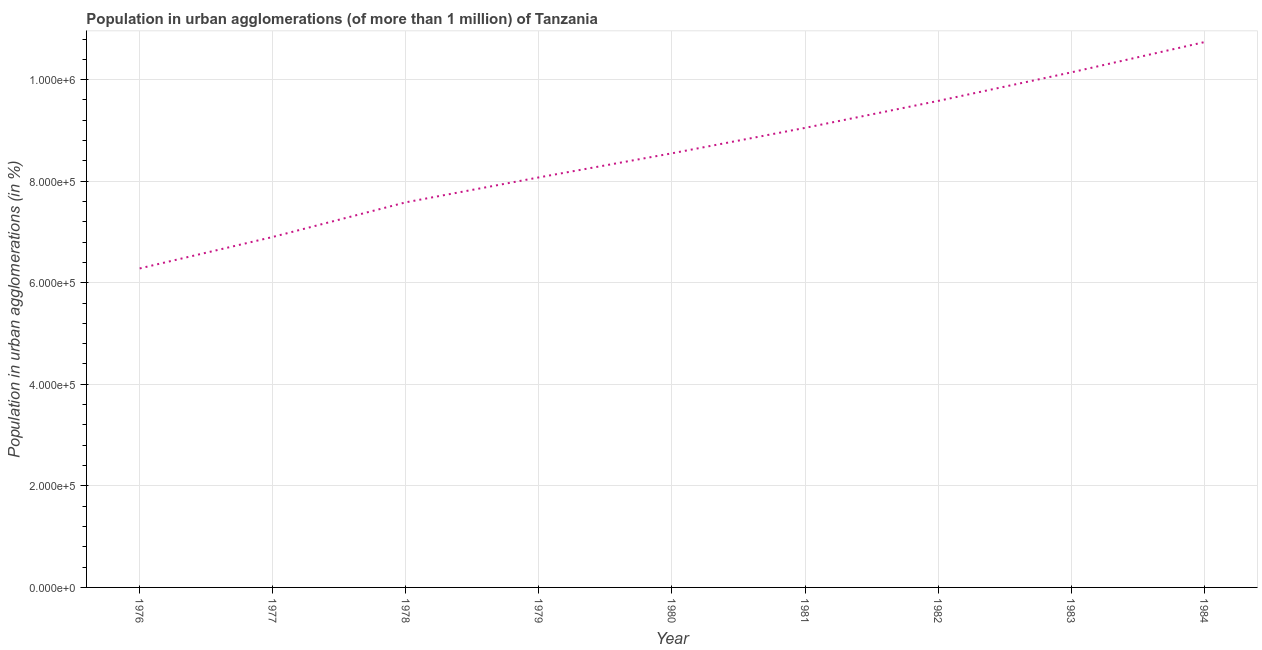What is the population in urban agglomerations in 1981?
Provide a short and direct response. 9.05e+05. Across all years, what is the maximum population in urban agglomerations?
Offer a terse response. 1.07e+06. Across all years, what is the minimum population in urban agglomerations?
Offer a very short reply. 6.28e+05. In which year was the population in urban agglomerations maximum?
Make the answer very short. 1984. In which year was the population in urban agglomerations minimum?
Provide a succinct answer. 1976. What is the sum of the population in urban agglomerations?
Your answer should be compact. 7.69e+06. What is the difference between the population in urban agglomerations in 1977 and 1978?
Your answer should be compact. -6.82e+04. What is the average population in urban agglomerations per year?
Give a very brief answer. 8.54e+05. What is the median population in urban agglomerations?
Give a very brief answer. 8.55e+05. What is the ratio of the population in urban agglomerations in 1977 to that in 1984?
Offer a terse response. 0.64. Is the difference between the population in urban agglomerations in 1976 and 1978 greater than the difference between any two years?
Offer a very short reply. No. What is the difference between the highest and the second highest population in urban agglomerations?
Your response must be concise. 5.96e+04. What is the difference between the highest and the lowest population in urban agglomerations?
Give a very brief answer. 4.46e+05. In how many years, is the population in urban agglomerations greater than the average population in urban agglomerations taken over all years?
Offer a terse response. 5. Does the population in urban agglomerations monotonically increase over the years?
Give a very brief answer. Yes. How many lines are there?
Provide a succinct answer. 1. How many years are there in the graph?
Your answer should be compact. 9. Does the graph contain any zero values?
Make the answer very short. No. What is the title of the graph?
Make the answer very short. Population in urban agglomerations (of more than 1 million) of Tanzania. What is the label or title of the X-axis?
Keep it short and to the point. Year. What is the label or title of the Y-axis?
Ensure brevity in your answer.  Population in urban agglomerations (in %). What is the Population in urban agglomerations (in %) in 1976?
Offer a very short reply. 6.28e+05. What is the Population in urban agglomerations (in %) of 1977?
Offer a very short reply. 6.90e+05. What is the Population in urban agglomerations (in %) of 1978?
Provide a short and direct response. 7.58e+05. What is the Population in urban agglomerations (in %) in 1979?
Offer a very short reply. 8.07e+05. What is the Population in urban agglomerations (in %) in 1980?
Provide a succinct answer. 8.55e+05. What is the Population in urban agglomerations (in %) of 1981?
Your answer should be compact. 9.05e+05. What is the Population in urban agglomerations (in %) in 1982?
Keep it short and to the point. 9.58e+05. What is the Population in urban agglomerations (in %) of 1983?
Provide a succinct answer. 1.01e+06. What is the Population in urban agglomerations (in %) in 1984?
Offer a very short reply. 1.07e+06. What is the difference between the Population in urban agglomerations (in %) in 1976 and 1977?
Give a very brief answer. -6.20e+04. What is the difference between the Population in urban agglomerations (in %) in 1976 and 1978?
Offer a terse response. -1.30e+05. What is the difference between the Population in urban agglomerations (in %) in 1976 and 1979?
Offer a terse response. -1.79e+05. What is the difference between the Population in urban agglomerations (in %) in 1976 and 1980?
Ensure brevity in your answer.  -2.27e+05. What is the difference between the Population in urban agglomerations (in %) in 1976 and 1981?
Your response must be concise. -2.77e+05. What is the difference between the Population in urban agglomerations (in %) in 1976 and 1982?
Make the answer very short. -3.30e+05. What is the difference between the Population in urban agglomerations (in %) in 1976 and 1983?
Offer a very short reply. -3.86e+05. What is the difference between the Population in urban agglomerations (in %) in 1976 and 1984?
Offer a very short reply. -4.46e+05. What is the difference between the Population in urban agglomerations (in %) in 1977 and 1978?
Offer a terse response. -6.82e+04. What is the difference between the Population in urban agglomerations (in %) in 1977 and 1979?
Keep it short and to the point. -1.17e+05. What is the difference between the Population in urban agglomerations (in %) in 1977 and 1980?
Keep it short and to the point. -1.65e+05. What is the difference between the Population in urban agglomerations (in %) in 1977 and 1981?
Make the answer very short. -2.15e+05. What is the difference between the Population in urban agglomerations (in %) in 1977 and 1982?
Offer a terse response. -2.68e+05. What is the difference between the Population in urban agglomerations (in %) in 1977 and 1983?
Give a very brief answer. -3.24e+05. What is the difference between the Population in urban agglomerations (in %) in 1977 and 1984?
Provide a short and direct response. -3.84e+05. What is the difference between the Population in urban agglomerations (in %) in 1978 and 1979?
Keep it short and to the point. -4.91e+04. What is the difference between the Population in urban agglomerations (in %) in 1978 and 1980?
Provide a succinct answer. -9.65e+04. What is the difference between the Population in urban agglomerations (in %) in 1978 and 1981?
Make the answer very short. -1.47e+05. What is the difference between the Population in urban agglomerations (in %) in 1978 and 1982?
Give a very brief answer. -2.00e+05. What is the difference between the Population in urban agglomerations (in %) in 1978 and 1983?
Offer a very short reply. -2.56e+05. What is the difference between the Population in urban agglomerations (in %) in 1978 and 1984?
Your response must be concise. -3.15e+05. What is the difference between the Population in urban agglomerations (in %) in 1979 and 1980?
Give a very brief answer. -4.74e+04. What is the difference between the Population in urban agglomerations (in %) in 1979 and 1981?
Your answer should be compact. -9.75e+04. What is the difference between the Population in urban agglomerations (in %) in 1979 and 1982?
Your answer should be compact. -1.51e+05. What is the difference between the Population in urban agglomerations (in %) in 1979 and 1983?
Give a very brief answer. -2.07e+05. What is the difference between the Population in urban agglomerations (in %) in 1979 and 1984?
Your answer should be very brief. -2.66e+05. What is the difference between the Population in urban agglomerations (in %) in 1980 and 1981?
Provide a short and direct response. -5.01e+04. What is the difference between the Population in urban agglomerations (in %) in 1980 and 1982?
Make the answer very short. -1.03e+05. What is the difference between the Population in urban agglomerations (in %) in 1980 and 1983?
Offer a terse response. -1.59e+05. What is the difference between the Population in urban agglomerations (in %) in 1980 and 1984?
Keep it short and to the point. -2.19e+05. What is the difference between the Population in urban agglomerations (in %) in 1981 and 1982?
Provide a succinct answer. -5.31e+04. What is the difference between the Population in urban agglomerations (in %) in 1981 and 1983?
Your answer should be very brief. -1.09e+05. What is the difference between the Population in urban agglomerations (in %) in 1981 and 1984?
Your answer should be very brief. -1.69e+05. What is the difference between the Population in urban agglomerations (in %) in 1982 and 1983?
Give a very brief answer. -5.62e+04. What is the difference between the Population in urban agglomerations (in %) in 1982 and 1984?
Your answer should be very brief. -1.16e+05. What is the difference between the Population in urban agglomerations (in %) in 1983 and 1984?
Provide a succinct answer. -5.96e+04. What is the ratio of the Population in urban agglomerations (in %) in 1976 to that in 1977?
Offer a very short reply. 0.91. What is the ratio of the Population in urban agglomerations (in %) in 1976 to that in 1978?
Make the answer very short. 0.83. What is the ratio of the Population in urban agglomerations (in %) in 1976 to that in 1979?
Offer a terse response. 0.78. What is the ratio of the Population in urban agglomerations (in %) in 1976 to that in 1980?
Make the answer very short. 0.73. What is the ratio of the Population in urban agglomerations (in %) in 1976 to that in 1981?
Keep it short and to the point. 0.69. What is the ratio of the Population in urban agglomerations (in %) in 1976 to that in 1982?
Your answer should be compact. 0.66. What is the ratio of the Population in urban agglomerations (in %) in 1976 to that in 1983?
Ensure brevity in your answer.  0.62. What is the ratio of the Population in urban agglomerations (in %) in 1976 to that in 1984?
Ensure brevity in your answer.  0.58. What is the ratio of the Population in urban agglomerations (in %) in 1977 to that in 1978?
Provide a short and direct response. 0.91. What is the ratio of the Population in urban agglomerations (in %) in 1977 to that in 1979?
Offer a terse response. 0.85. What is the ratio of the Population in urban agglomerations (in %) in 1977 to that in 1980?
Your answer should be compact. 0.81. What is the ratio of the Population in urban agglomerations (in %) in 1977 to that in 1981?
Provide a succinct answer. 0.76. What is the ratio of the Population in urban agglomerations (in %) in 1977 to that in 1982?
Offer a terse response. 0.72. What is the ratio of the Population in urban agglomerations (in %) in 1977 to that in 1983?
Your answer should be very brief. 0.68. What is the ratio of the Population in urban agglomerations (in %) in 1977 to that in 1984?
Keep it short and to the point. 0.64. What is the ratio of the Population in urban agglomerations (in %) in 1978 to that in 1979?
Provide a succinct answer. 0.94. What is the ratio of the Population in urban agglomerations (in %) in 1978 to that in 1980?
Ensure brevity in your answer.  0.89. What is the ratio of the Population in urban agglomerations (in %) in 1978 to that in 1981?
Provide a succinct answer. 0.84. What is the ratio of the Population in urban agglomerations (in %) in 1978 to that in 1982?
Your answer should be very brief. 0.79. What is the ratio of the Population in urban agglomerations (in %) in 1978 to that in 1983?
Make the answer very short. 0.75. What is the ratio of the Population in urban agglomerations (in %) in 1978 to that in 1984?
Keep it short and to the point. 0.71. What is the ratio of the Population in urban agglomerations (in %) in 1979 to that in 1980?
Make the answer very short. 0.94. What is the ratio of the Population in urban agglomerations (in %) in 1979 to that in 1981?
Provide a short and direct response. 0.89. What is the ratio of the Population in urban agglomerations (in %) in 1979 to that in 1982?
Your response must be concise. 0.84. What is the ratio of the Population in urban agglomerations (in %) in 1979 to that in 1983?
Give a very brief answer. 0.8. What is the ratio of the Population in urban agglomerations (in %) in 1979 to that in 1984?
Keep it short and to the point. 0.75. What is the ratio of the Population in urban agglomerations (in %) in 1980 to that in 1981?
Keep it short and to the point. 0.94. What is the ratio of the Population in urban agglomerations (in %) in 1980 to that in 1982?
Offer a terse response. 0.89. What is the ratio of the Population in urban agglomerations (in %) in 1980 to that in 1983?
Give a very brief answer. 0.84. What is the ratio of the Population in urban agglomerations (in %) in 1980 to that in 1984?
Keep it short and to the point. 0.8. What is the ratio of the Population in urban agglomerations (in %) in 1981 to that in 1982?
Offer a terse response. 0.94. What is the ratio of the Population in urban agglomerations (in %) in 1981 to that in 1983?
Keep it short and to the point. 0.89. What is the ratio of the Population in urban agglomerations (in %) in 1981 to that in 1984?
Your response must be concise. 0.84. What is the ratio of the Population in urban agglomerations (in %) in 1982 to that in 1983?
Ensure brevity in your answer.  0.94. What is the ratio of the Population in urban agglomerations (in %) in 1982 to that in 1984?
Your answer should be compact. 0.89. What is the ratio of the Population in urban agglomerations (in %) in 1983 to that in 1984?
Offer a terse response. 0.94. 